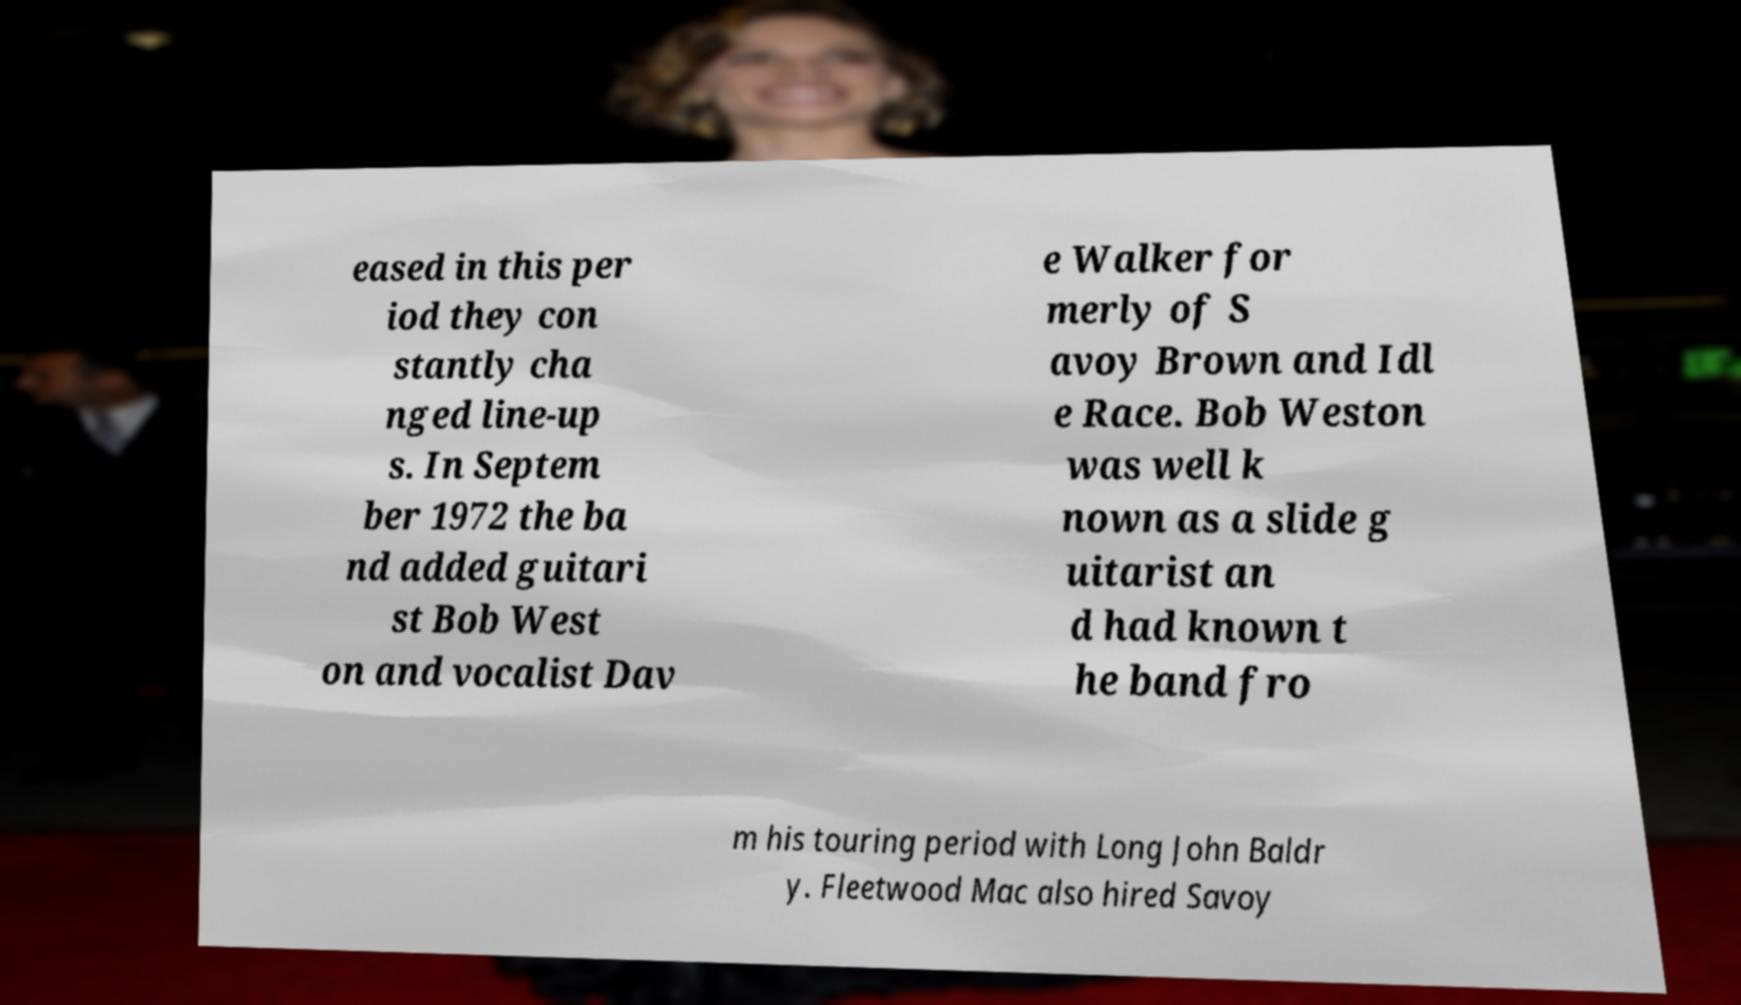Could you assist in decoding the text presented in this image and type it out clearly? eased in this per iod they con stantly cha nged line-up s. In Septem ber 1972 the ba nd added guitari st Bob West on and vocalist Dav e Walker for merly of S avoy Brown and Idl e Race. Bob Weston was well k nown as a slide g uitarist an d had known t he band fro m his touring period with Long John Baldr y. Fleetwood Mac also hired Savoy 